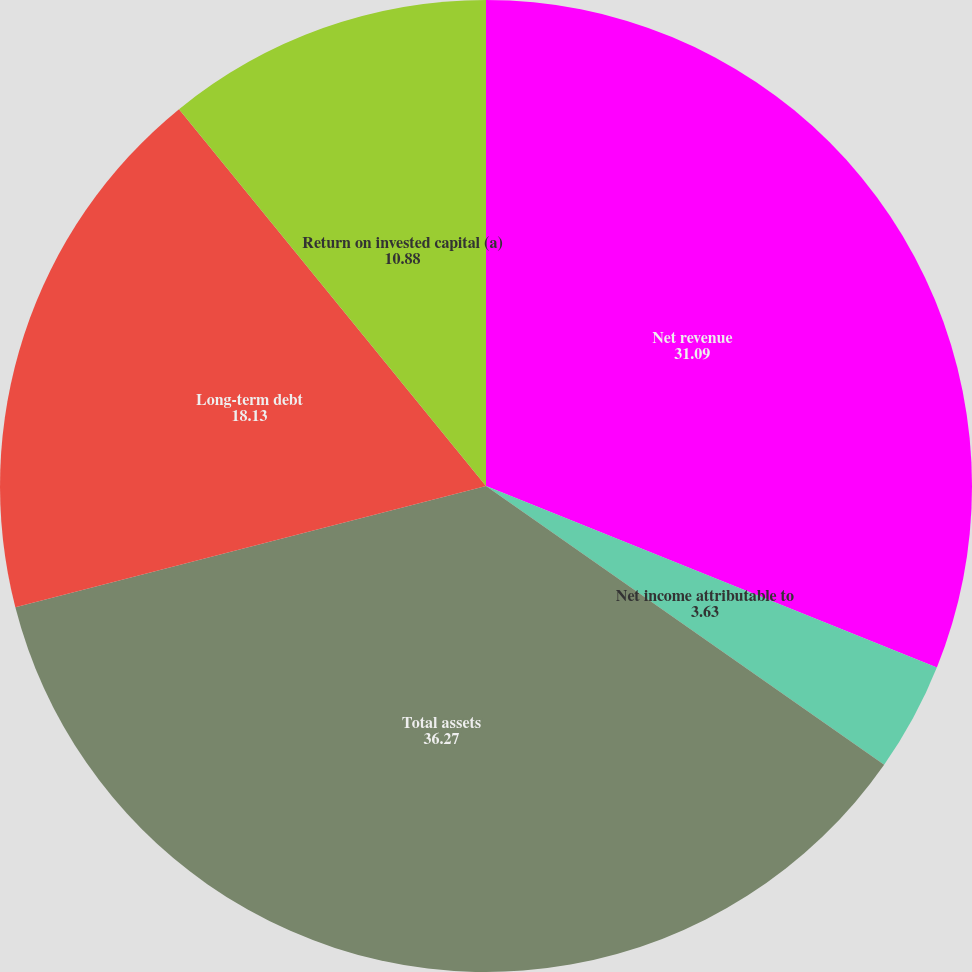Convert chart to OTSL. <chart><loc_0><loc_0><loc_500><loc_500><pie_chart><fcel>Net revenue<fcel>Net income attributable to<fcel>Cash dividends declared per<fcel>Total assets<fcel>Long-term debt<fcel>Return on invested capital (a)<nl><fcel>31.09%<fcel>3.63%<fcel>0.0%<fcel>36.27%<fcel>18.13%<fcel>10.88%<nl></chart> 